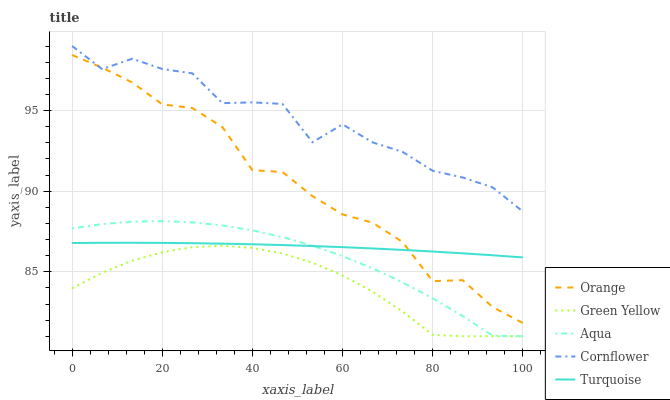Does Green Yellow have the minimum area under the curve?
Answer yes or no. Yes. Does Cornflower have the maximum area under the curve?
Answer yes or no. Yes. Does Turquoise have the minimum area under the curve?
Answer yes or no. No. Does Turquoise have the maximum area under the curve?
Answer yes or no. No. Is Turquoise the smoothest?
Answer yes or no. Yes. Is Cornflower the roughest?
Answer yes or no. Yes. Is Cornflower the smoothest?
Answer yes or no. No. Is Turquoise the roughest?
Answer yes or no. No. Does Green Yellow have the lowest value?
Answer yes or no. Yes. Does Turquoise have the lowest value?
Answer yes or no. No. Does Cornflower have the highest value?
Answer yes or no. Yes. Does Turquoise have the highest value?
Answer yes or no. No. Is Turquoise less than Cornflower?
Answer yes or no. Yes. Is Cornflower greater than Turquoise?
Answer yes or no. Yes. Does Orange intersect Cornflower?
Answer yes or no. Yes. Is Orange less than Cornflower?
Answer yes or no. No. Is Orange greater than Cornflower?
Answer yes or no. No. Does Turquoise intersect Cornflower?
Answer yes or no. No. 